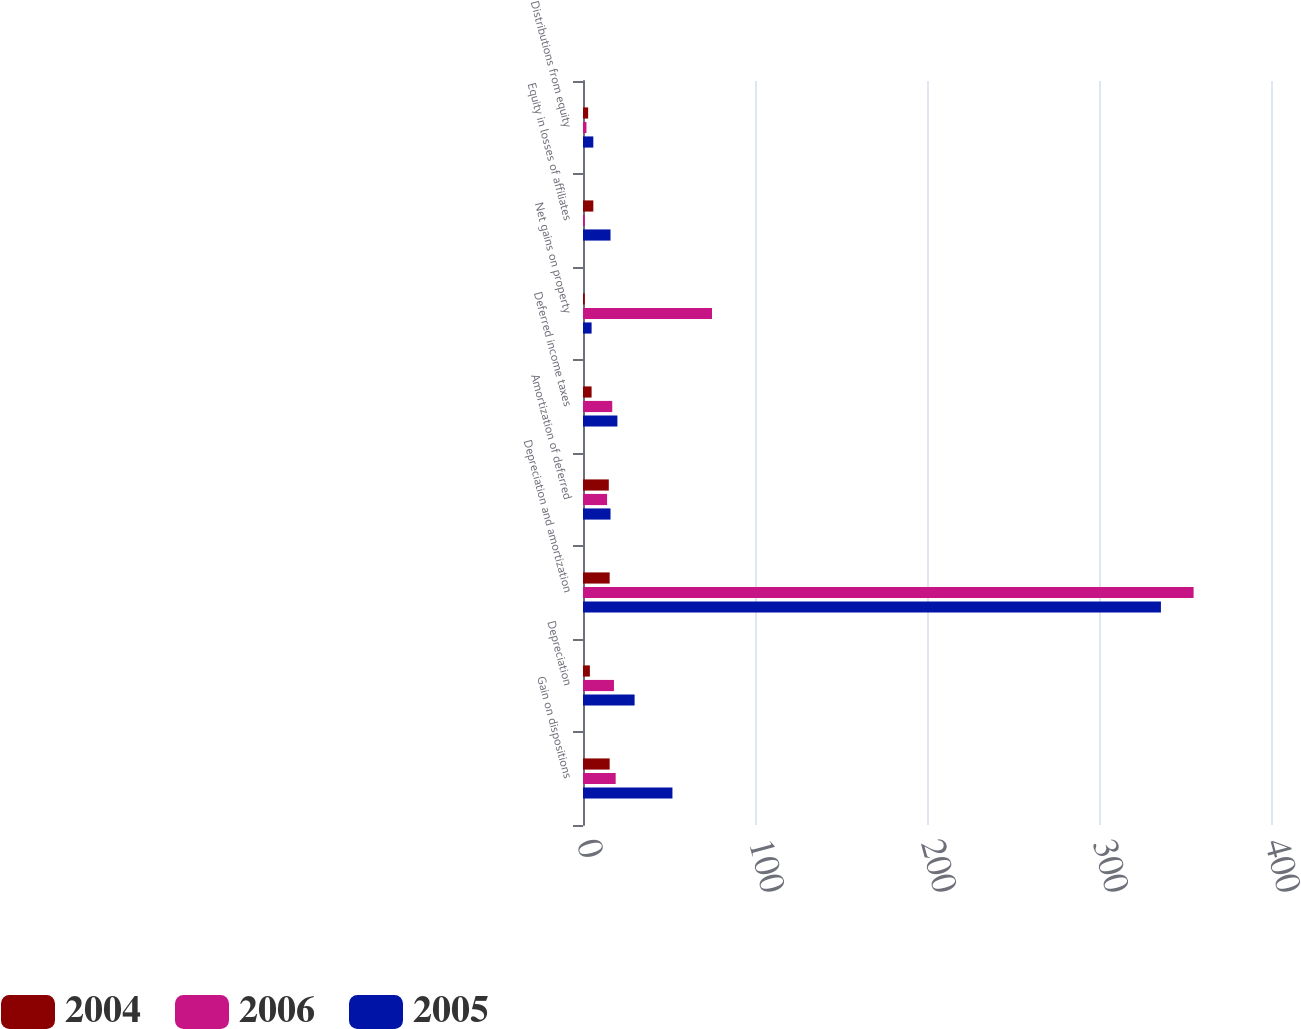Convert chart. <chart><loc_0><loc_0><loc_500><loc_500><stacked_bar_chart><ecel><fcel>Gain on dispositions<fcel>Depreciation<fcel>Depreciation and amortization<fcel>Amortization of deferred<fcel>Deferred income taxes<fcel>Net gains on property<fcel>Equity in losses of affiliates<fcel>Distributions from equity<nl><fcel>2004<fcel>15.5<fcel>4<fcel>15.5<fcel>15<fcel>5<fcel>1<fcel>6<fcel>3<nl><fcel>2006<fcel>19<fcel>18<fcel>355<fcel>14<fcel>17<fcel>75<fcel>1<fcel>2<nl><fcel>2005<fcel>52<fcel>30<fcel>336<fcel>16<fcel>20<fcel>5<fcel>16<fcel>6<nl></chart> 